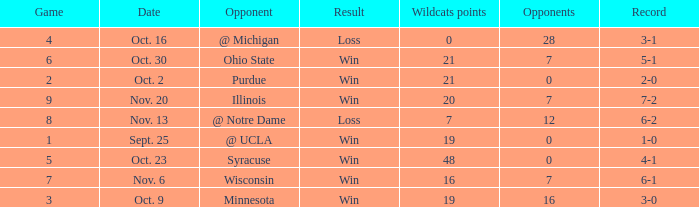What game number did the Wildcats play Purdue? 2.0. 